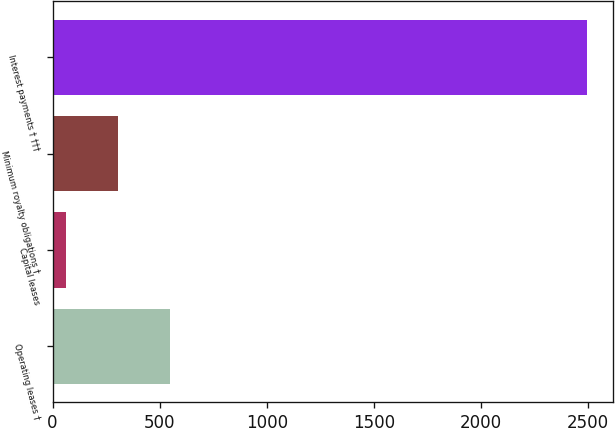Convert chart to OTSL. <chart><loc_0><loc_0><loc_500><loc_500><bar_chart><fcel>Operating leases †<fcel>Capital leases<fcel>Minimum royalty obligations †<fcel>Interest payments † †††<nl><fcel>550.8<fcel>65<fcel>307.9<fcel>2494<nl></chart> 